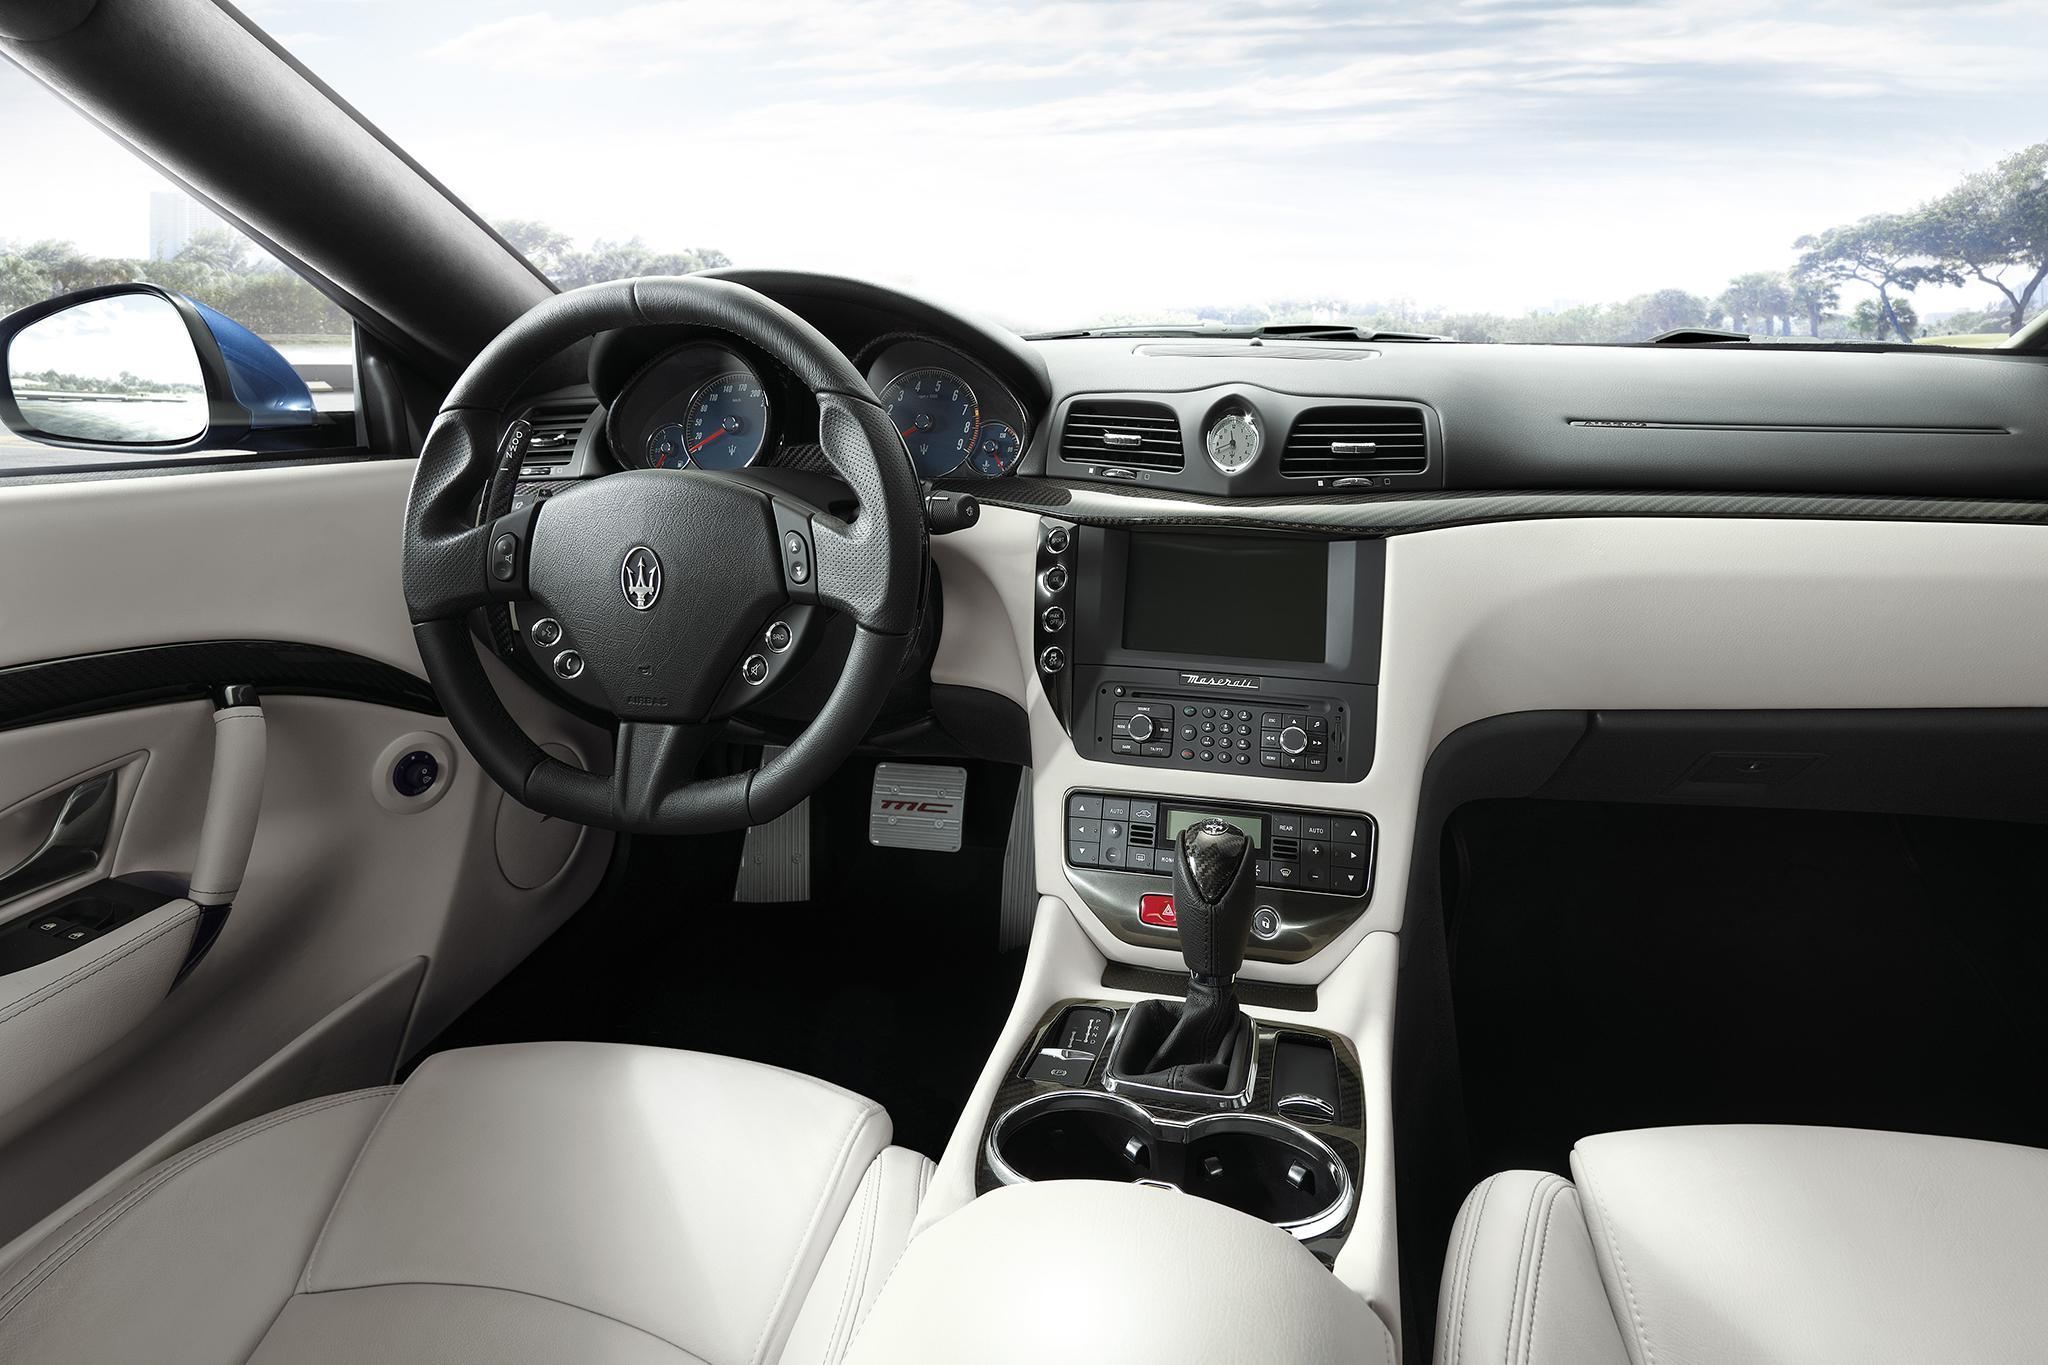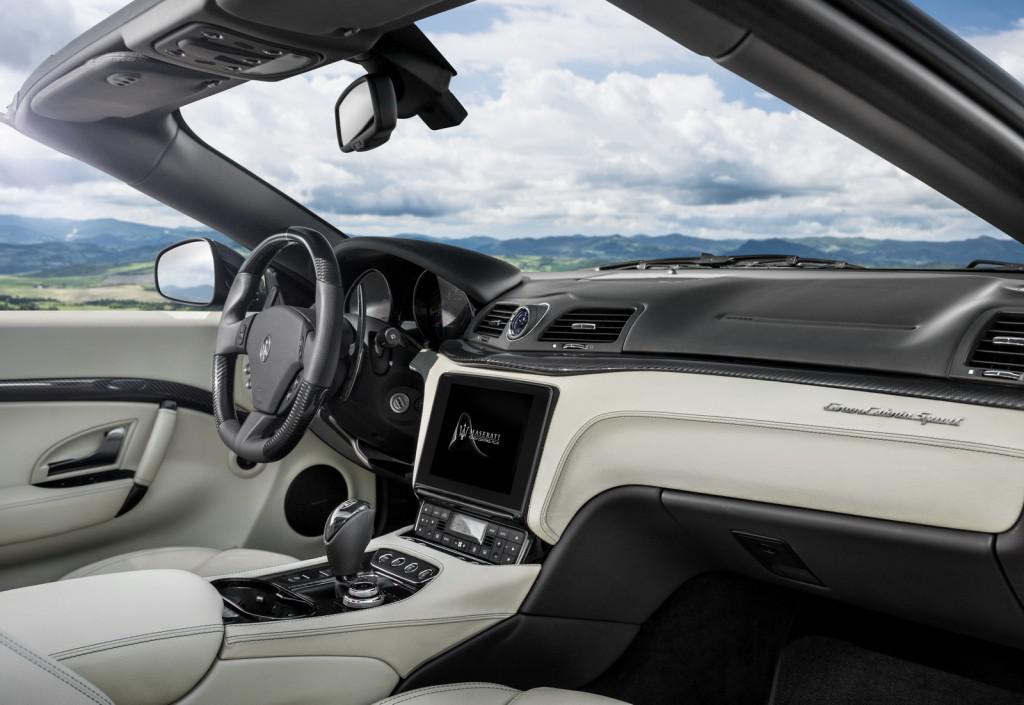The first image is the image on the left, the second image is the image on the right. For the images displayed, is the sentence "The steering wheel is visible on both cars, but the back seat is not." factually correct? Answer yes or no. Yes. The first image is the image on the left, the second image is the image on the right. Given the left and right images, does the statement "Both car interiors show white upholstery, and no other color upholstery on the seats." hold true? Answer yes or no. Yes. 